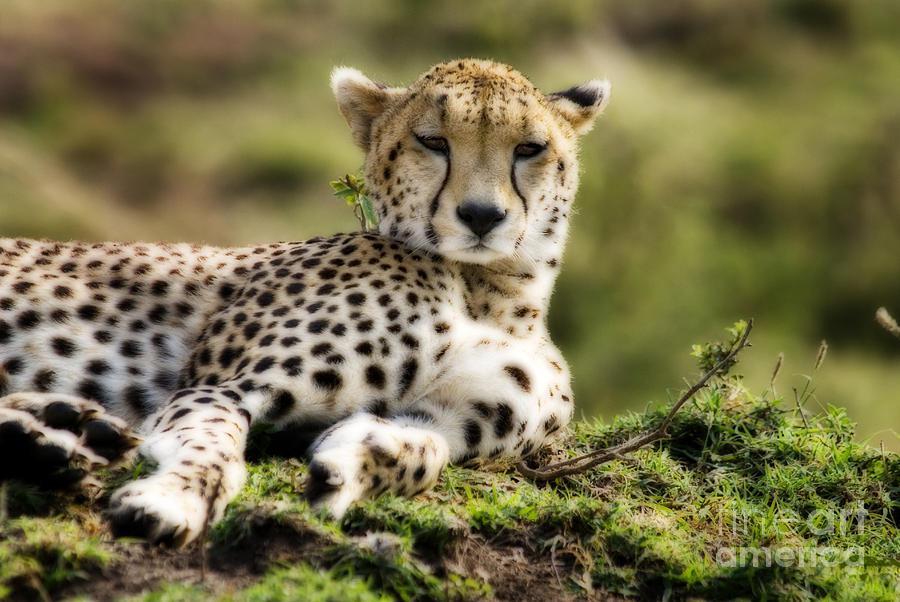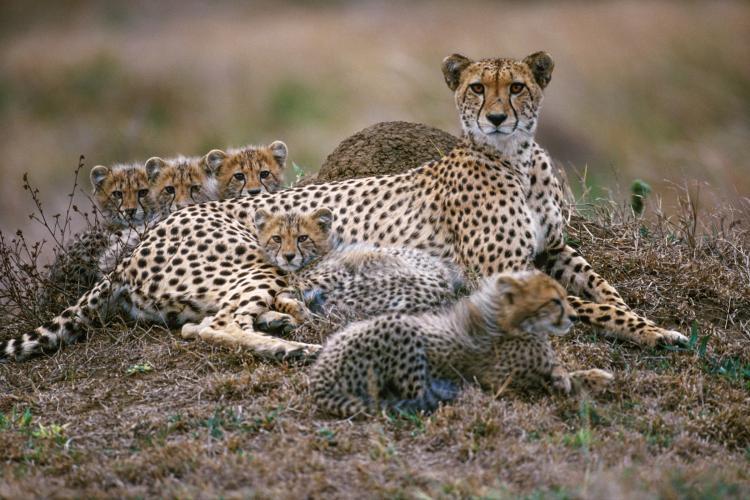The first image is the image on the left, the second image is the image on the right. For the images shown, is this caption "All of the cheetahs are lying down." true? Answer yes or no. Yes. The first image is the image on the left, the second image is the image on the right. For the images displayed, is the sentence "Each image includes an adult cheetah reclining on the ground with its head raised." factually correct? Answer yes or no. Yes. 